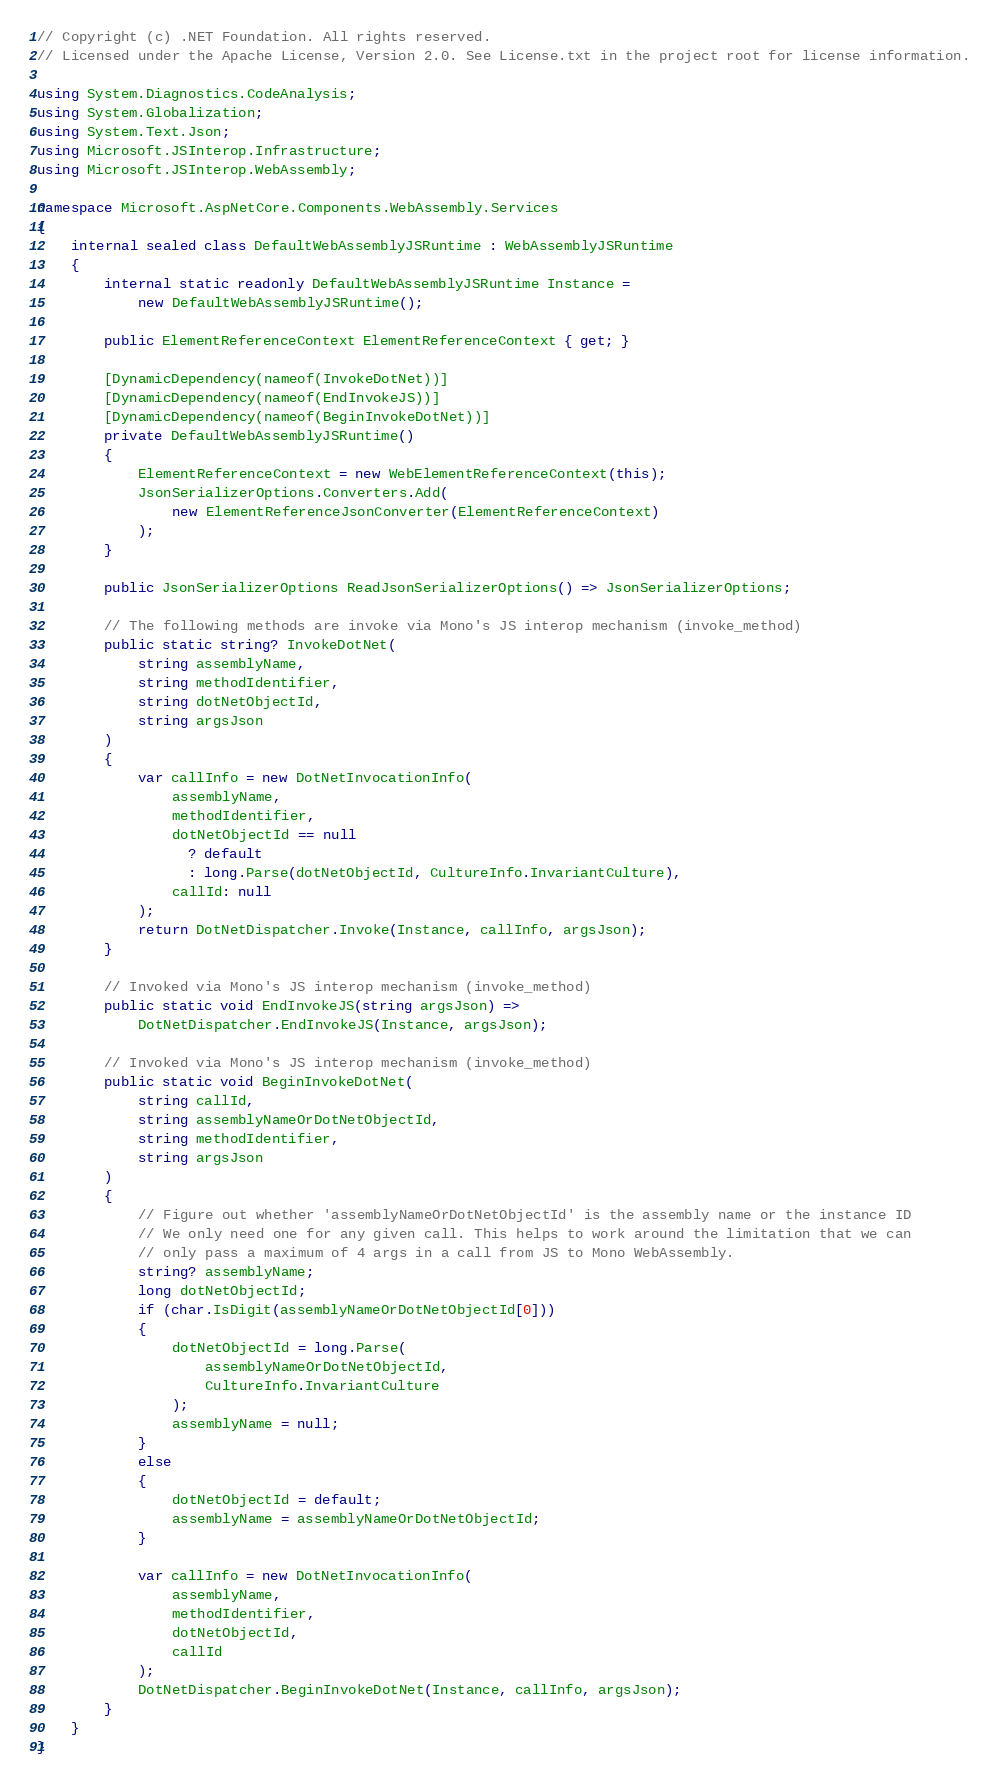<code> <loc_0><loc_0><loc_500><loc_500><_C#_>// Copyright (c) .NET Foundation. All rights reserved.
// Licensed under the Apache License, Version 2.0. See License.txt in the project root for license information.

using System.Diagnostics.CodeAnalysis;
using System.Globalization;
using System.Text.Json;
using Microsoft.JSInterop.Infrastructure;
using Microsoft.JSInterop.WebAssembly;

namespace Microsoft.AspNetCore.Components.WebAssembly.Services
{
    internal sealed class DefaultWebAssemblyJSRuntime : WebAssemblyJSRuntime
    {
        internal static readonly DefaultWebAssemblyJSRuntime Instance =
            new DefaultWebAssemblyJSRuntime();

        public ElementReferenceContext ElementReferenceContext { get; }

        [DynamicDependency(nameof(InvokeDotNet))]
        [DynamicDependency(nameof(EndInvokeJS))]
        [DynamicDependency(nameof(BeginInvokeDotNet))]
        private DefaultWebAssemblyJSRuntime()
        {
            ElementReferenceContext = new WebElementReferenceContext(this);
            JsonSerializerOptions.Converters.Add(
                new ElementReferenceJsonConverter(ElementReferenceContext)
            );
        }

        public JsonSerializerOptions ReadJsonSerializerOptions() => JsonSerializerOptions;

        // The following methods are invoke via Mono's JS interop mechanism (invoke_method)
        public static string? InvokeDotNet(
            string assemblyName,
            string methodIdentifier,
            string dotNetObjectId,
            string argsJson
        )
        {
            var callInfo = new DotNetInvocationInfo(
                assemblyName,
                methodIdentifier,
                dotNetObjectId == null
                  ? default
                  : long.Parse(dotNetObjectId, CultureInfo.InvariantCulture),
                callId: null
            );
            return DotNetDispatcher.Invoke(Instance, callInfo, argsJson);
        }

        // Invoked via Mono's JS interop mechanism (invoke_method)
        public static void EndInvokeJS(string argsJson) =>
            DotNetDispatcher.EndInvokeJS(Instance, argsJson);

        // Invoked via Mono's JS interop mechanism (invoke_method)
        public static void BeginInvokeDotNet(
            string callId,
            string assemblyNameOrDotNetObjectId,
            string methodIdentifier,
            string argsJson
        )
        {
            // Figure out whether 'assemblyNameOrDotNetObjectId' is the assembly name or the instance ID
            // We only need one for any given call. This helps to work around the limitation that we can
            // only pass a maximum of 4 args in a call from JS to Mono WebAssembly.
            string? assemblyName;
            long dotNetObjectId;
            if (char.IsDigit(assemblyNameOrDotNetObjectId[0]))
            {
                dotNetObjectId = long.Parse(
                    assemblyNameOrDotNetObjectId,
                    CultureInfo.InvariantCulture
                );
                assemblyName = null;
            }
            else
            {
                dotNetObjectId = default;
                assemblyName = assemblyNameOrDotNetObjectId;
            }

            var callInfo = new DotNetInvocationInfo(
                assemblyName,
                methodIdentifier,
                dotNetObjectId,
                callId
            );
            DotNetDispatcher.BeginInvokeDotNet(Instance, callInfo, argsJson);
        }
    }
}
</code> 